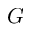<formula> <loc_0><loc_0><loc_500><loc_500>G</formula> 